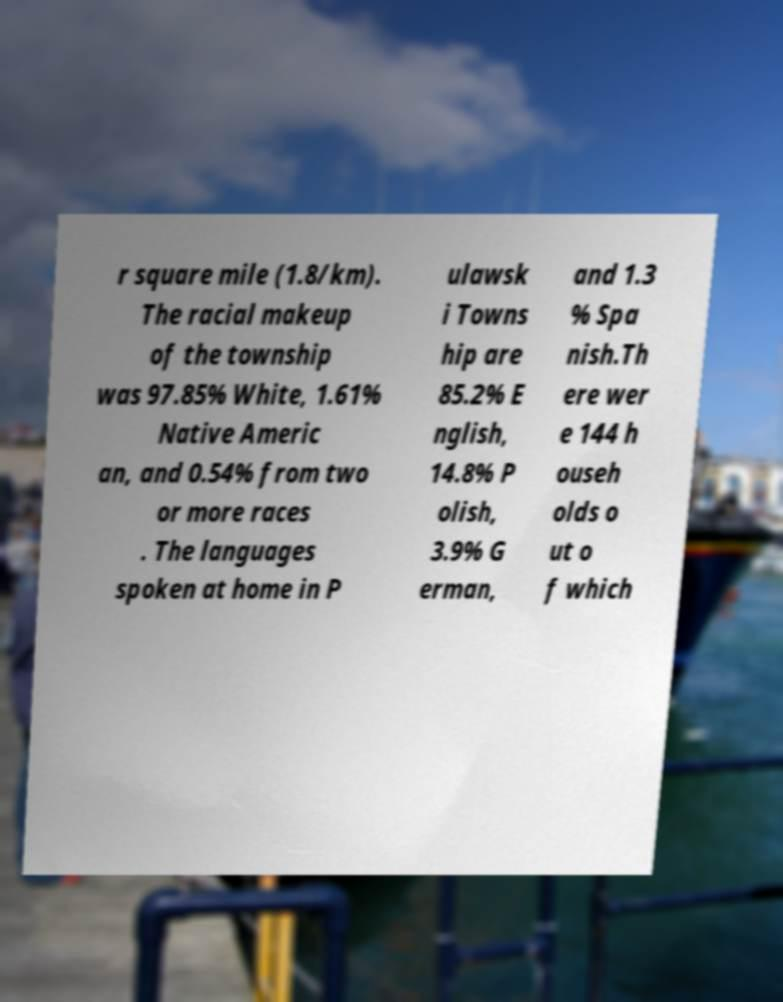Can you read and provide the text displayed in the image?This photo seems to have some interesting text. Can you extract and type it out for me? r square mile (1.8/km). The racial makeup of the township was 97.85% White, 1.61% Native Americ an, and 0.54% from two or more races . The languages spoken at home in P ulawsk i Towns hip are 85.2% E nglish, 14.8% P olish, 3.9% G erman, and 1.3 % Spa nish.Th ere wer e 144 h ouseh olds o ut o f which 